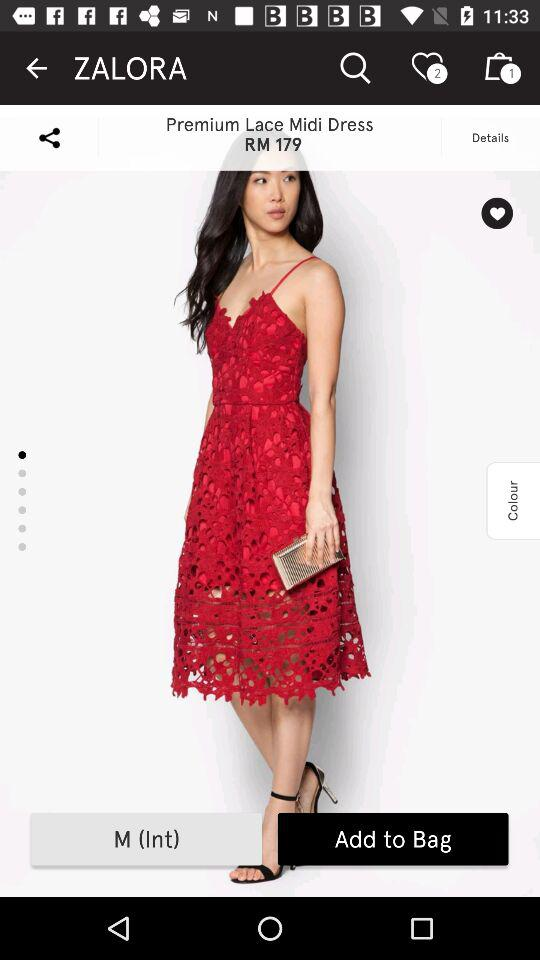What is the price of "Midi Dress"? The price of "Midi Dress" is RM179. 